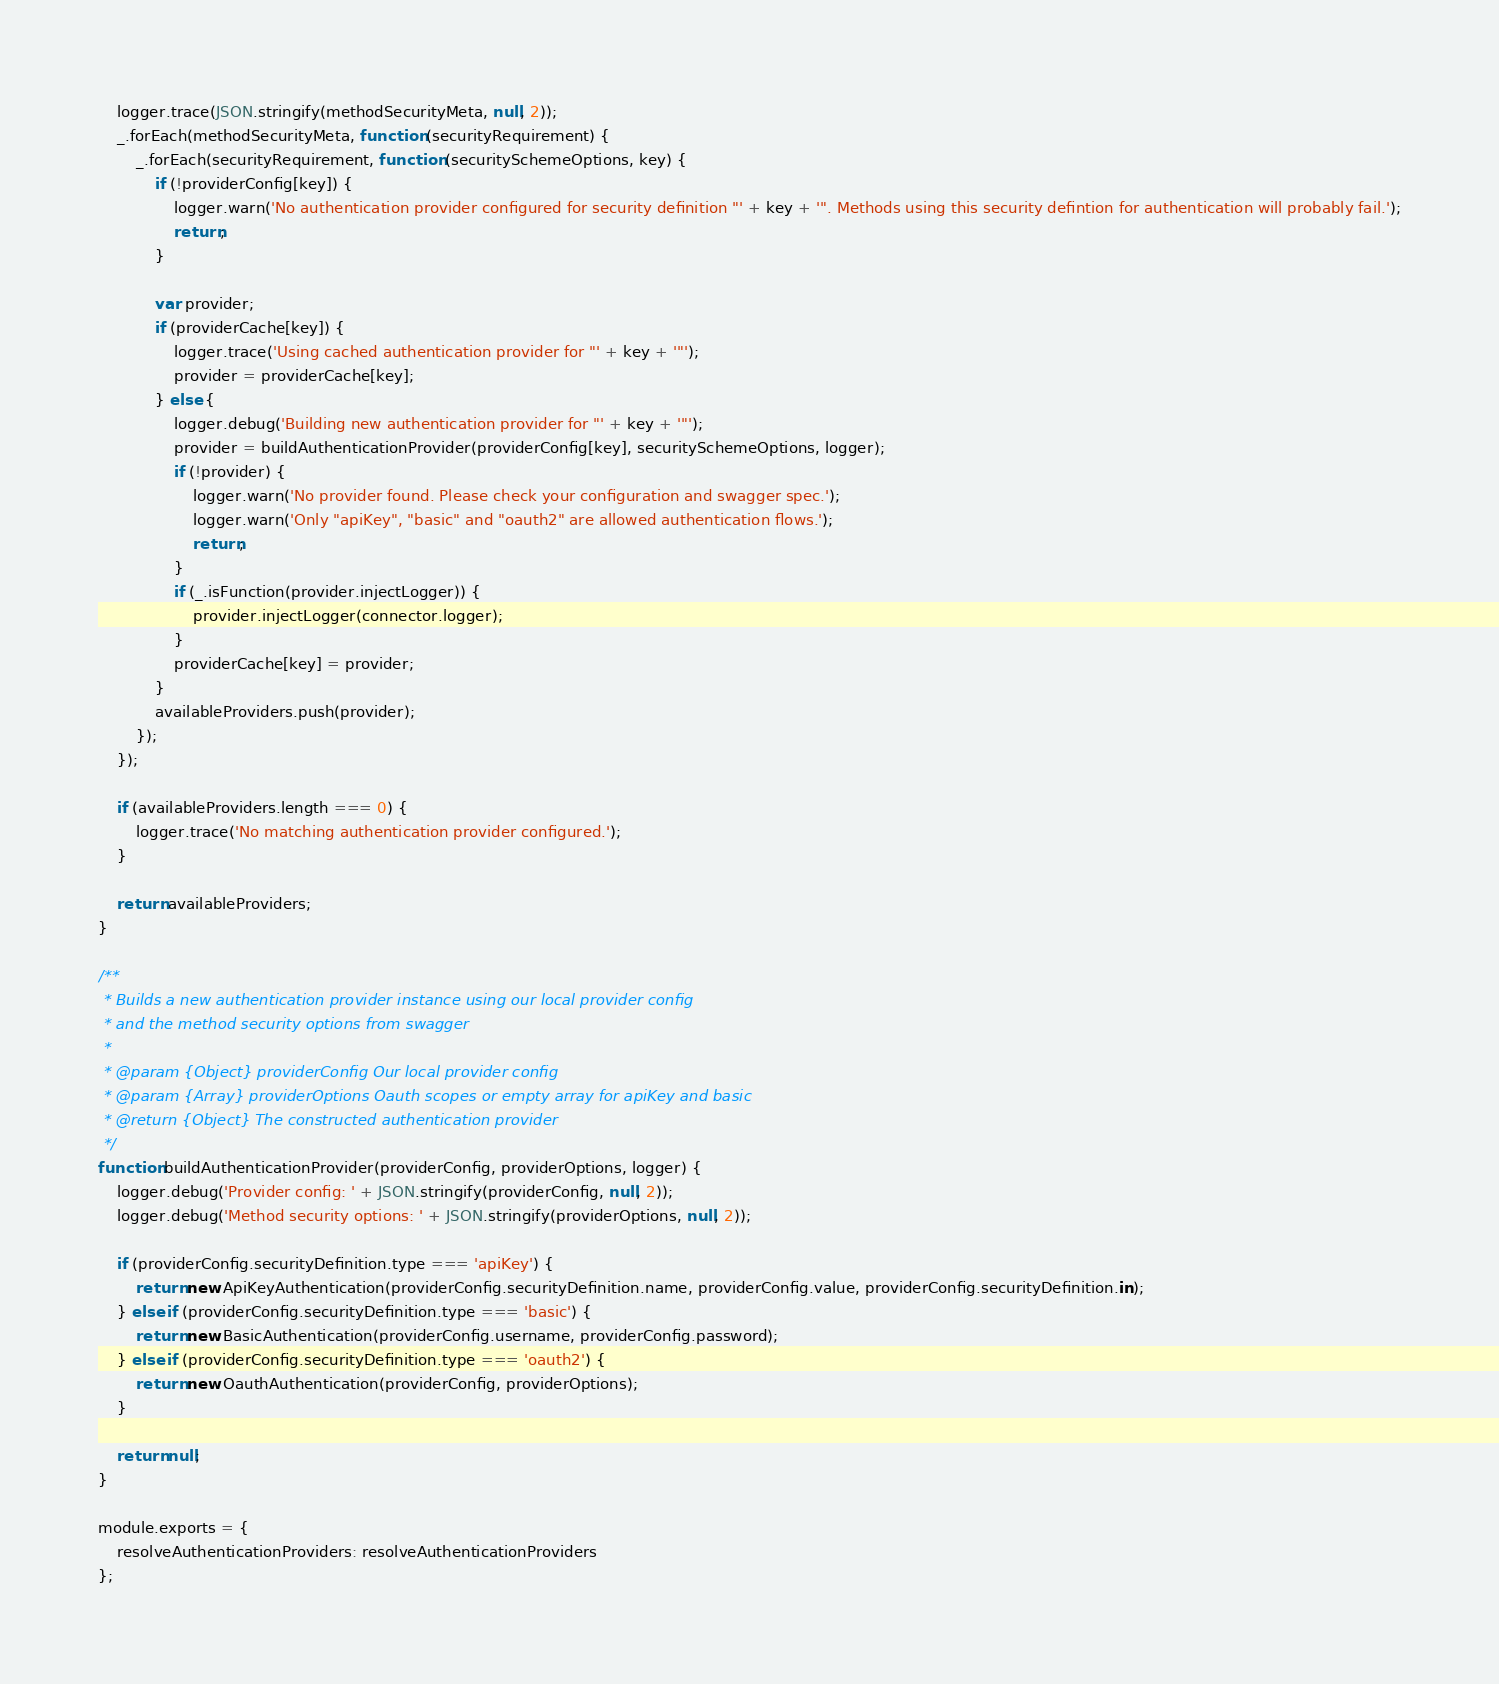<code> <loc_0><loc_0><loc_500><loc_500><_JavaScript_>	logger.trace(JSON.stringify(methodSecurityMeta, null, 2));
	_.forEach(methodSecurityMeta, function (securityRequirement) {
		_.forEach(securityRequirement, function (securitySchemeOptions, key) {
			if (!providerConfig[key]) {
				logger.warn('No authentication provider configured for security definition "' + key + '". Methods using this security defintion for authentication will probably fail.');
				return;
			}

			var provider;
			if (providerCache[key]) {
				logger.trace('Using cached authentication provider for "' + key + '"');
				provider = providerCache[key];
			} else {
				logger.debug('Building new authentication provider for "' + key + '"');
				provider = buildAuthenticationProvider(providerConfig[key], securitySchemeOptions, logger);
				if (!provider) {
					logger.warn('No provider found. Please check your configuration and swagger spec.');
					logger.warn('Only "apiKey", "basic" and "oauth2" are allowed authentication flows.');
					return;
				}
				if (_.isFunction(provider.injectLogger)) {
					provider.injectLogger(connector.logger);
				}
				providerCache[key] = provider;
			}
			availableProviders.push(provider);
		});
	});

	if (availableProviders.length === 0) {
		logger.trace('No matching authentication provider configured.');
	}

	return availableProviders;
}

/**
 * Builds a new authentication provider instance using our local provider config
 * and the method security options from swagger
 *
 * @param {Object} providerConfig Our local provider config
 * @param {Array} providerOptions Oauth scopes or empty array for apiKey and basic
 * @return {Object} The constructed authentication provider
 */
function buildAuthenticationProvider(providerConfig, providerOptions, logger) {
	logger.debug('Provider config: ' + JSON.stringify(providerConfig, null, 2));
	logger.debug('Method security options: ' + JSON.stringify(providerOptions, null, 2));

	if (providerConfig.securityDefinition.type === 'apiKey') {
		return new ApiKeyAuthentication(providerConfig.securityDefinition.name, providerConfig.value, providerConfig.securityDefinition.in);
	} else if (providerConfig.securityDefinition.type === 'basic') {
		return new BasicAuthentication(providerConfig.username, providerConfig.password);
	} else if (providerConfig.securityDefinition.type === 'oauth2') {
		return new OauthAuthentication(providerConfig, providerOptions);
	}

	return null;
}

module.exports = {
	resolveAuthenticationProviders: resolveAuthenticationProviders
};
</code> 